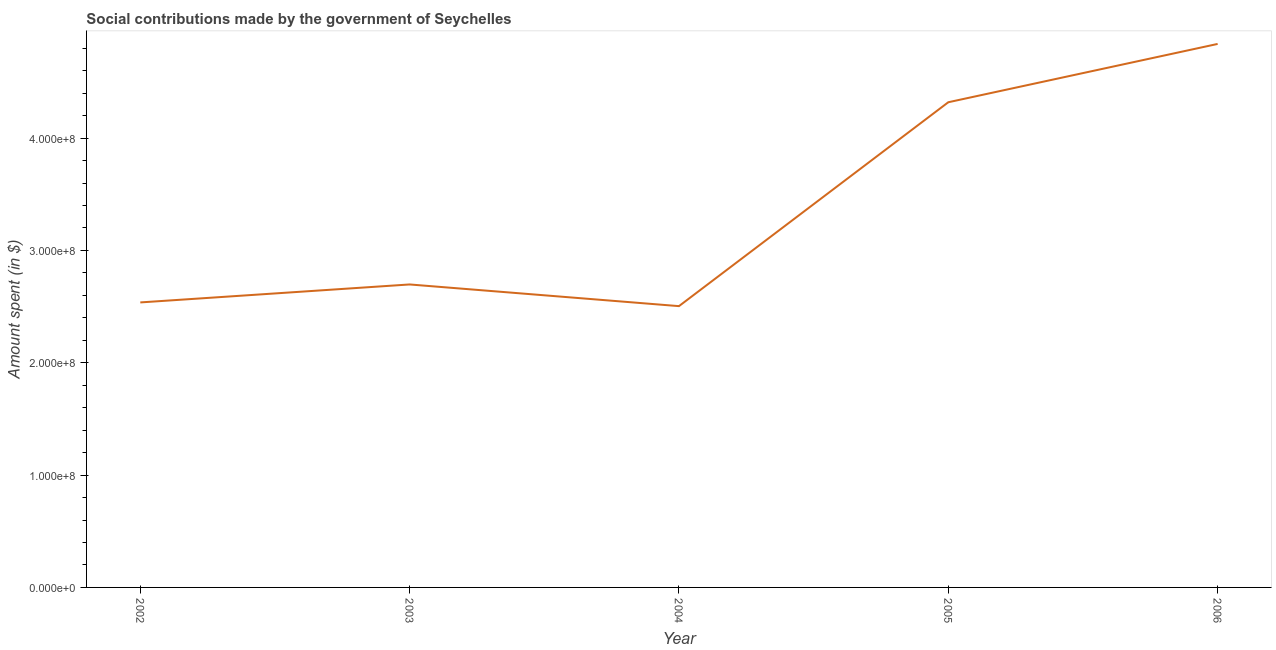What is the amount spent in making social contributions in 2005?
Your response must be concise. 4.32e+08. Across all years, what is the maximum amount spent in making social contributions?
Provide a short and direct response. 4.84e+08. Across all years, what is the minimum amount spent in making social contributions?
Your response must be concise. 2.50e+08. In which year was the amount spent in making social contributions maximum?
Make the answer very short. 2006. What is the sum of the amount spent in making social contributions?
Provide a short and direct response. 1.69e+09. What is the difference between the amount spent in making social contributions in 2003 and 2004?
Offer a terse response. 1.93e+07. What is the average amount spent in making social contributions per year?
Your answer should be compact. 3.38e+08. What is the median amount spent in making social contributions?
Keep it short and to the point. 2.70e+08. Do a majority of the years between 2004 and 2002 (inclusive) have amount spent in making social contributions greater than 360000000 $?
Your answer should be compact. No. What is the ratio of the amount spent in making social contributions in 2002 to that in 2004?
Offer a terse response. 1.01. What is the difference between the highest and the second highest amount spent in making social contributions?
Ensure brevity in your answer.  5.19e+07. Is the sum of the amount spent in making social contributions in 2004 and 2005 greater than the maximum amount spent in making social contributions across all years?
Provide a succinct answer. Yes. What is the difference between the highest and the lowest amount spent in making social contributions?
Provide a short and direct response. 2.33e+08. In how many years, is the amount spent in making social contributions greater than the average amount spent in making social contributions taken over all years?
Offer a very short reply. 2. Does the amount spent in making social contributions monotonically increase over the years?
Offer a terse response. No. What is the difference between two consecutive major ticks on the Y-axis?
Make the answer very short. 1.00e+08. Are the values on the major ticks of Y-axis written in scientific E-notation?
Your answer should be very brief. Yes. What is the title of the graph?
Offer a very short reply. Social contributions made by the government of Seychelles. What is the label or title of the X-axis?
Your response must be concise. Year. What is the label or title of the Y-axis?
Keep it short and to the point. Amount spent (in $). What is the Amount spent (in $) of 2002?
Make the answer very short. 2.54e+08. What is the Amount spent (in $) in 2003?
Ensure brevity in your answer.  2.70e+08. What is the Amount spent (in $) in 2004?
Provide a succinct answer. 2.50e+08. What is the Amount spent (in $) of 2005?
Your response must be concise. 4.32e+08. What is the Amount spent (in $) of 2006?
Keep it short and to the point. 4.84e+08. What is the difference between the Amount spent (in $) in 2002 and 2003?
Provide a succinct answer. -1.60e+07. What is the difference between the Amount spent (in $) in 2002 and 2004?
Offer a terse response. 3.30e+06. What is the difference between the Amount spent (in $) in 2002 and 2005?
Your answer should be very brief. -1.78e+08. What is the difference between the Amount spent (in $) in 2002 and 2006?
Provide a succinct answer. -2.30e+08. What is the difference between the Amount spent (in $) in 2003 and 2004?
Offer a terse response. 1.93e+07. What is the difference between the Amount spent (in $) in 2003 and 2005?
Offer a terse response. -1.62e+08. What is the difference between the Amount spent (in $) in 2003 and 2006?
Give a very brief answer. -2.14e+08. What is the difference between the Amount spent (in $) in 2004 and 2005?
Offer a terse response. -1.82e+08. What is the difference between the Amount spent (in $) in 2004 and 2006?
Your answer should be very brief. -2.33e+08. What is the difference between the Amount spent (in $) in 2005 and 2006?
Offer a very short reply. -5.19e+07. What is the ratio of the Amount spent (in $) in 2002 to that in 2003?
Your response must be concise. 0.94. What is the ratio of the Amount spent (in $) in 2002 to that in 2004?
Give a very brief answer. 1.01. What is the ratio of the Amount spent (in $) in 2002 to that in 2005?
Give a very brief answer. 0.59. What is the ratio of the Amount spent (in $) in 2002 to that in 2006?
Your answer should be compact. 0.52. What is the ratio of the Amount spent (in $) in 2003 to that in 2004?
Offer a very short reply. 1.08. What is the ratio of the Amount spent (in $) in 2003 to that in 2005?
Give a very brief answer. 0.62. What is the ratio of the Amount spent (in $) in 2003 to that in 2006?
Your answer should be very brief. 0.56. What is the ratio of the Amount spent (in $) in 2004 to that in 2005?
Your answer should be very brief. 0.58. What is the ratio of the Amount spent (in $) in 2004 to that in 2006?
Provide a succinct answer. 0.52. What is the ratio of the Amount spent (in $) in 2005 to that in 2006?
Your answer should be compact. 0.89. 